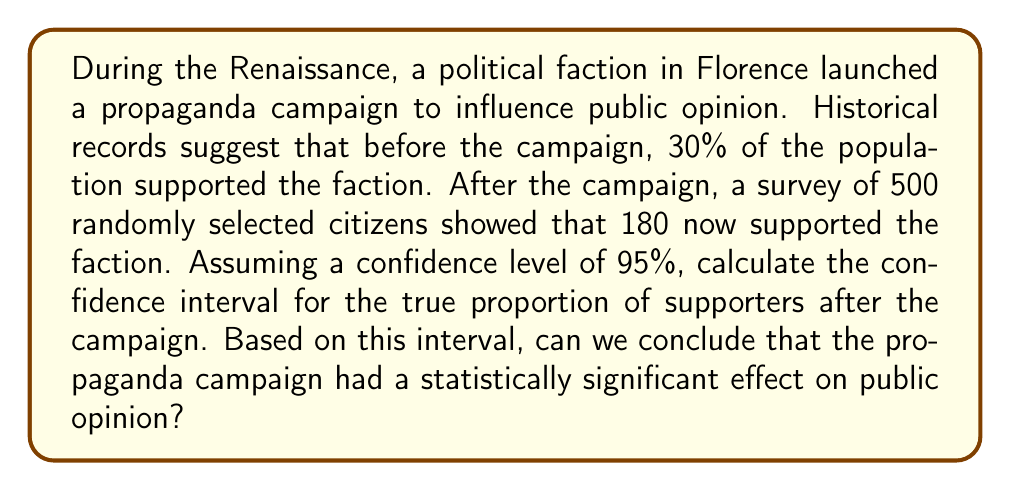Solve this math problem. To solve this problem, we'll use the following steps:

1. Calculate the sample proportion
2. Determine the critical value for a 95% confidence level
3. Calculate the margin of error
4. Compute the confidence interval
5. Compare the confidence interval with the initial proportion

Step 1: Calculate the sample proportion
$$\hat{p} = \frac{180}{500} = 0.36$$

Step 2: Determine the critical value
For a 95% confidence level, the critical value (z-score) is 1.96.

Step 3: Calculate the margin of error
The formula for margin of error is:
$$E = z \sqrt{\frac{\hat{p}(1-\hat{p})}{n}}$$

Where:
$z$ = critical value (1.96)
$\hat{p}$ = sample proportion (0.36)
$n$ = sample size (500)

$$E = 1.96 \sqrt{\frac{0.36(1-0.36)}{500}} = 0.0420$$

Step 4: Compute the confidence interval
The confidence interval is given by:
$$(\hat{p} - E, \hat{p} + E)$$

$$(0.36 - 0.0420, 0.36 + 0.0420)$$
$$(0.3180, 0.4020)$$

Step 5: Compare the confidence interval with the initial proportion
The initial proportion was 0.30 (30%). This value falls outside our calculated confidence interval of (0.3180, 0.4020).
Answer: The 95% confidence interval for the true proportion of supporters after the campaign is (0.3180, 0.4020). Since the initial proportion (0.30) falls outside this interval, we can conclude that the propaganda campaign had a statistically significant effect on public opinion at the 95% confidence level. 